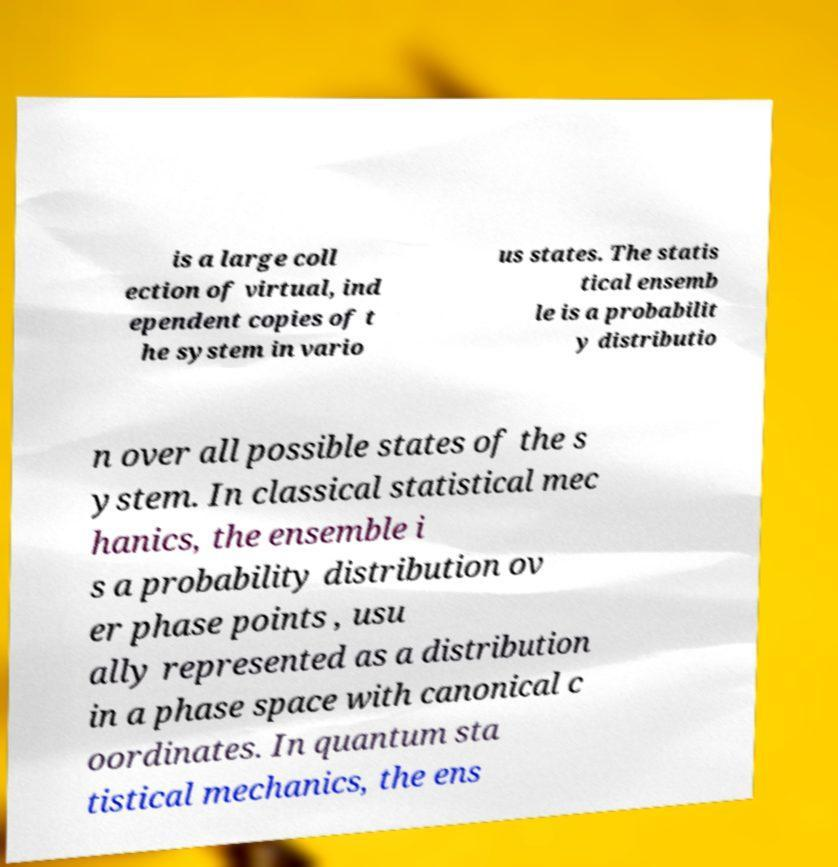For documentation purposes, I need the text within this image transcribed. Could you provide that? is a large coll ection of virtual, ind ependent copies of t he system in vario us states. The statis tical ensemb le is a probabilit y distributio n over all possible states of the s ystem. In classical statistical mec hanics, the ensemble i s a probability distribution ov er phase points , usu ally represented as a distribution in a phase space with canonical c oordinates. In quantum sta tistical mechanics, the ens 